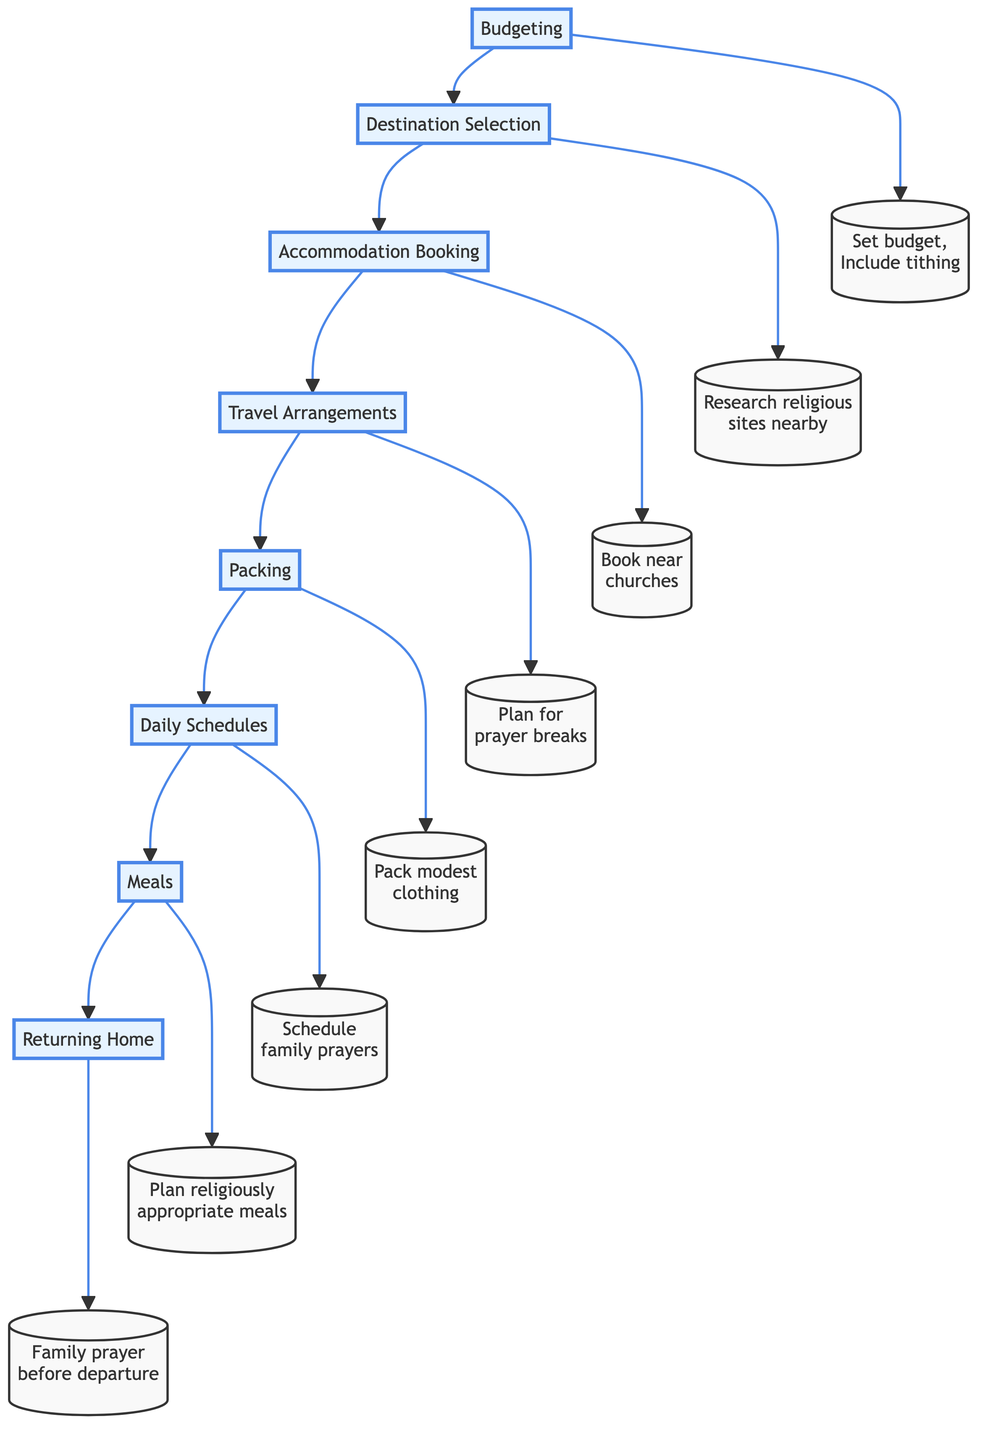What is the first step in the vacation planning process? The diagram indicates that the first step is "Budgeting," as it is the initial node leading to the selection of the destination.
Answer: Budgeting How many steps are there in total for planning the vacation? By counting the nodes in the diagram, there are eight steps, including "Budgeting" through to "Returning Home."
Answer: Eight What activity is associated with the "Meals" step? The primary activity under "Meals" listed in the diagram is "Plan religiously appropriate meals," indicating a focus on dietary guidelines.
Answer: Plan religiously appropriate meals What comes after "Daily Schedules"? Following the "Daily Schedules" step in the diagram is the "Meals" step, demonstrating the order of activities planned.
Answer: Meals What is a specific consideration during "Travel Arrangements"? The "Travel Arrangements" step highlights the need to "Plan for prayer breaks during long travels," which ensures that religious practices are maintained while traveling.
Answer: Plan for prayer breaks What should be packed for the trip according to the "Packing" step? The "Packing" step emphasizes the importance of including "modest clothing appropriate for church or religious gatherings," aligning with maintaining religious values.
Answer: Modest clothing What is the last activity listed before returning home? Before returning home, the final step includes discussing and reflecting on the vacation experiences as a family, as outlined in the "Returning Home" section.
Answer: Discuss and reflect on the vacation experiences What ensures a smooth transition during the return journey? "Family prayer before departure" is a key part of the "Returning Home" section that helps provide a sense of closure and reflection for a smooth transition back home.
Answer: Family prayer before departure Which step involves checking hotel policies? The step focused on checking hotel policies is "Accommodation Booking," where guests need to ensure compliance with their religious principles.
Answer: Accommodation Booking What type of restaurants should be identified according to the "Meals" step? The "Meals" step suggests identifying "restaurants that offer family-friendly and religiously appropriate meals," aligning dining choices with religious values.
Answer: Family-friendly and religiously appropriate meals 